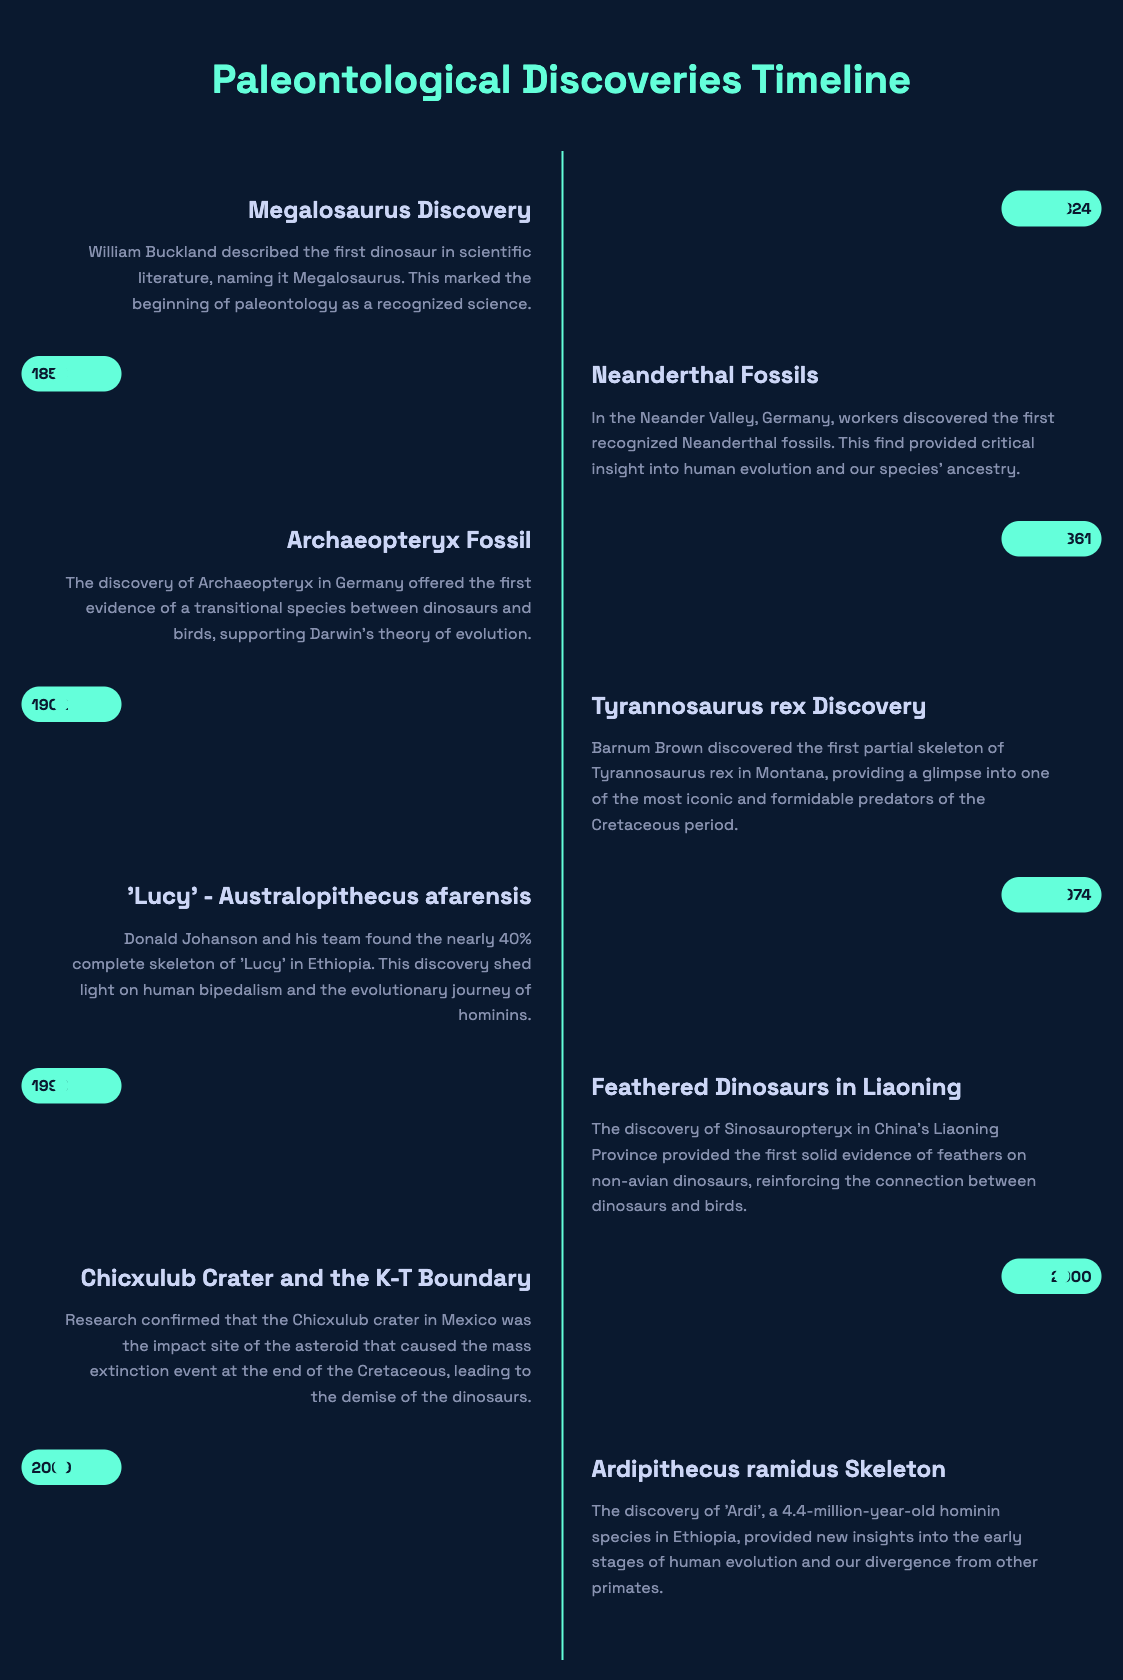what year was the Megalosaurus discovered? The Megalosaurus was discovered in 1824, as indicated in the timeline.
Answer: 1824 who discovered the first Neanderthal fossils? The first Neanderthal fossils were discovered by workers in Neander Valley, Germany.
Answer: workers what key transitional species was discovered in 1861? The key transitional species discovered in 1861 was Archaeopteryx.
Answer: Archaeopteryx which dinosaur's skeleton was discovered by Barnum Brown? Barnum Brown discovered the skeleton of Tyrannosaurus rex.
Answer: Tyrannosaurus rex what percentage of Lucy's skeleton is complete? Lucy's skeleton was nearly 40% complete, as stated in the document.
Answer: 40% what significant find was made in Liaoning Province in 1996? The significant find made in Liaoning Province was the discovery of feathered dinosaurs, specifically Sinosauropteryx.
Answer: Sinosauropteryx what was confirmed about the Chicxulub crater in 2000? It was confirmed that the Chicxulub crater was the impact site of the asteroid that caused a mass extinction event.
Answer: impact site which hominin species was discovered in 2009? The hominin species discovered in 2009 was Ardipithecus ramidus.
Answer: Ardipithecus ramidus 